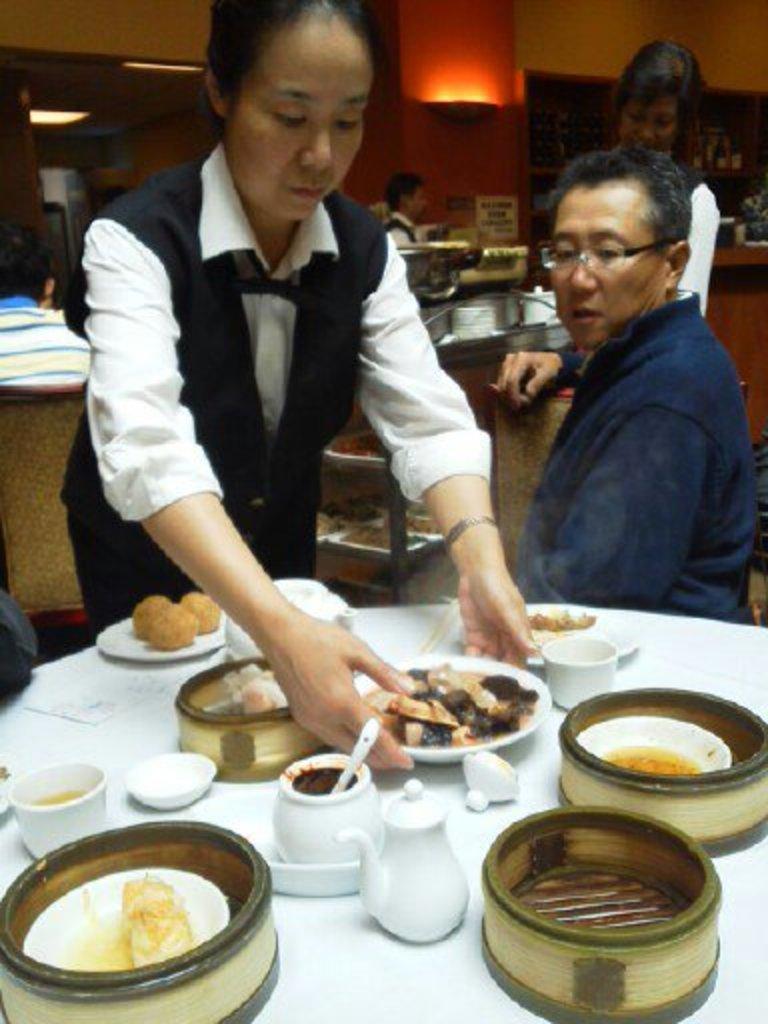Please provide a concise description of this image. Bottom of the image there is a table, on the table there are some plates, cups, saucer, bowls and food. Behind the table a woman is standing and holding a plate. Top right side of the image a man is sitting and watching. Behind him a woman is standing and there are some plates and bowls. Top of the image there is wall. Top left side of the image a person is sitting on a chair. 